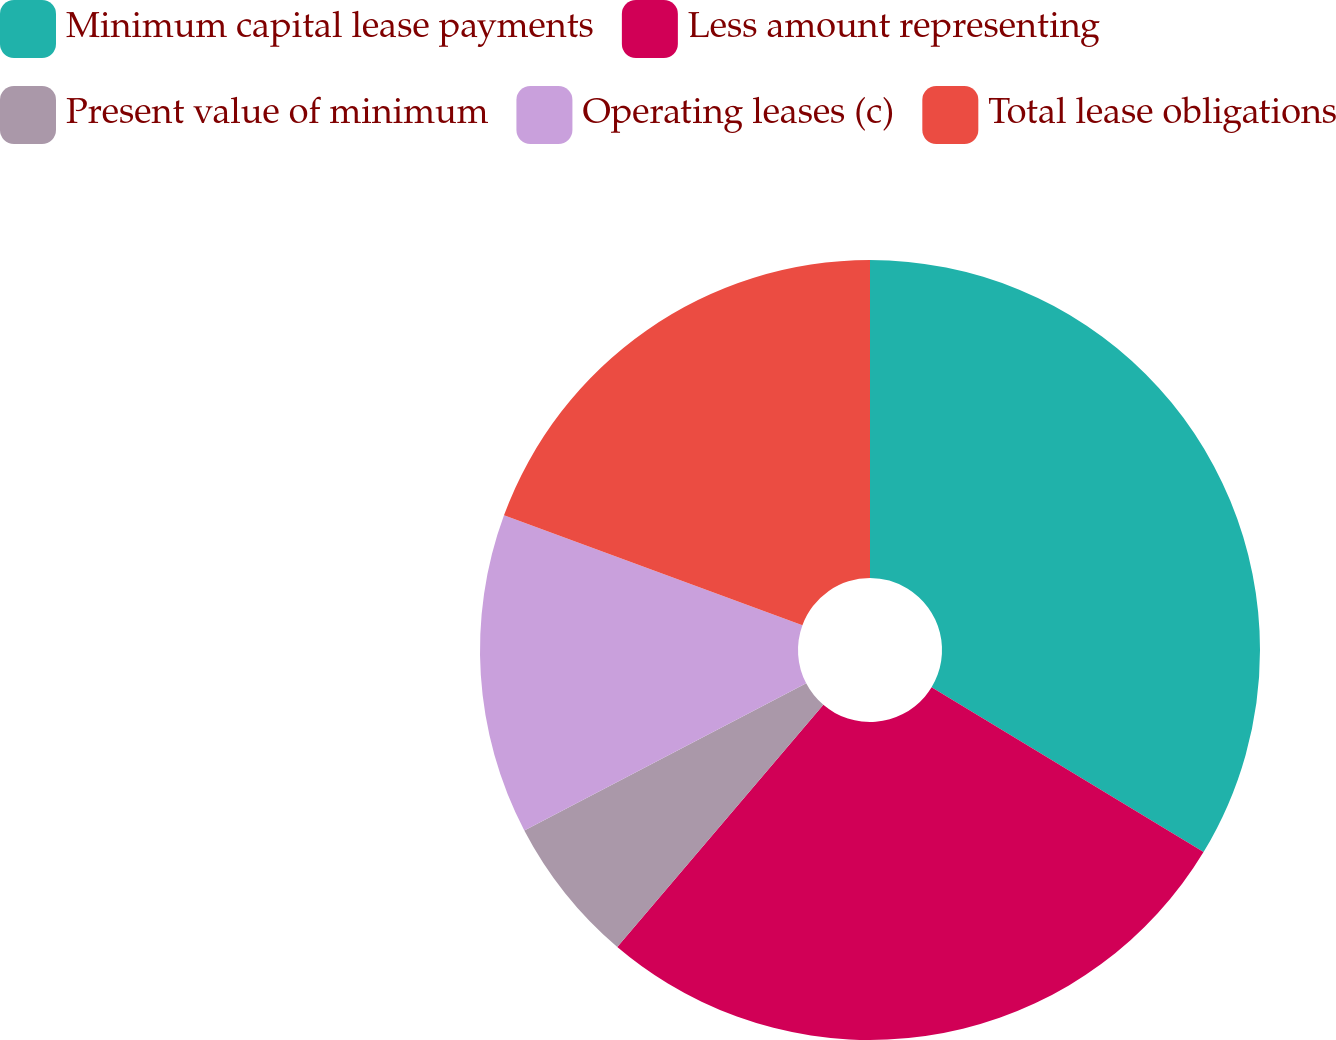Convert chart to OTSL. <chart><loc_0><loc_0><loc_500><loc_500><pie_chart><fcel>Minimum capital lease payments<fcel>Less amount representing<fcel>Present value of minimum<fcel>Operating leases (c)<fcel>Total lease obligations<nl><fcel>33.67%<fcel>27.55%<fcel>6.12%<fcel>13.27%<fcel>19.39%<nl></chart> 